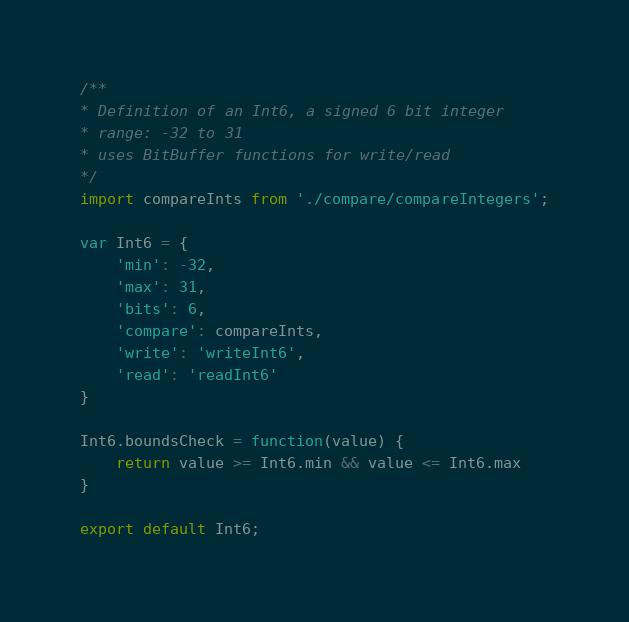<code> <loc_0><loc_0><loc_500><loc_500><_JavaScript_>/**
* Definition of an Int6, a signed 6 bit integer
* range: -32 to 31
* uses BitBuffer functions for write/read
*/
import compareInts from './compare/compareIntegers';

var Int6 = {
    'min': -32,
    'max': 31, 
    'bits': 6,
    'compare': compareInts,
    'write': 'writeInt6',
    'read': 'readInt6'
}

Int6.boundsCheck = function(value) {
	return value >= Int6.min && value <= Int6.max
}

export default Int6;</code> 